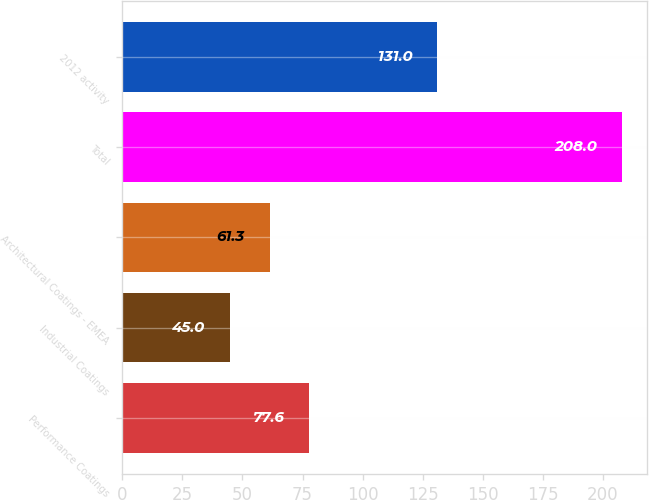Convert chart to OTSL. <chart><loc_0><loc_0><loc_500><loc_500><bar_chart><fcel>Performance Coatings<fcel>Industrial Coatings<fcel>Architectural Coatings - EMEA<fcel>Total<fcel>2012 activity<nl><fcel>77.6<fcel>45<fcel>61.3<fcel>208<fcel>131<nl></chart> 